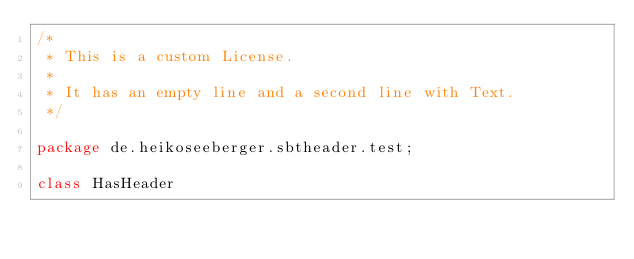Convert code to text. <code><loc_0><loc_0><loc_500><loc_500><_Scala_>/*
 * This is a custom License.
 *
 * It has an empty line and a second line with Text.
 */

package de.heikoseeberger.sbtheader.test;

class HasHeader
</code> 